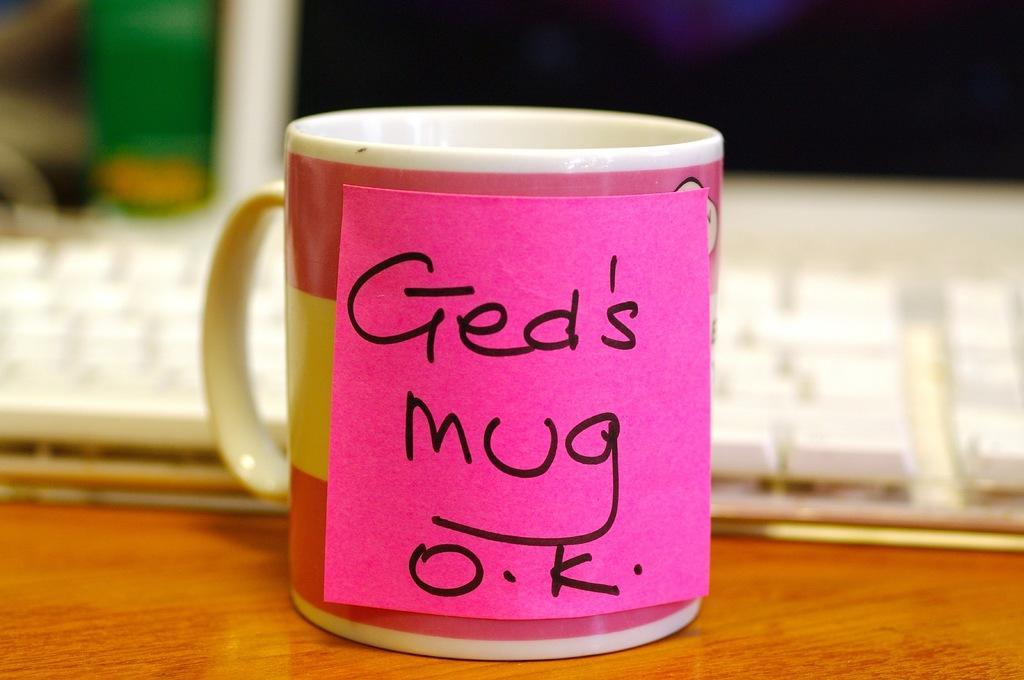<image>
Provide a brief description of the given image. A sticky note that reads Ged's Mug O.K. is on a pink and white mug in front of a computer. 